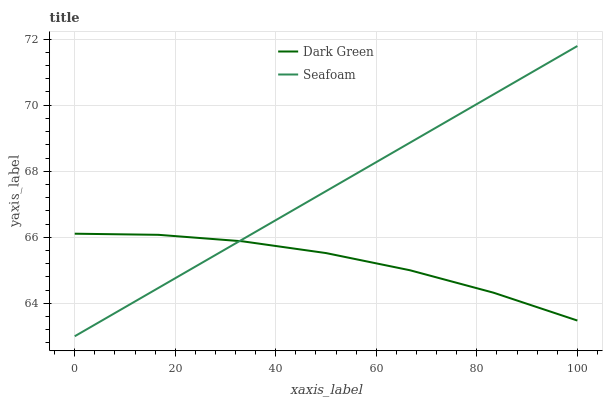Does Dark Green have the minimum area under the curve?
Answer yes or no. Yes. Does Seafoam have the maximum area under the curve?
Answer yes or no. Yes. Does Dark Green have the maximum area under the curve?
Answer yes or no. No. Is Seafoam the smoothest?
Answer yes or no. Yes. Is Dark Green the roughest?
Answer yes or no. Yes. Is Dark Green the smoothest?
Answer yes or no. No. Does Seafoam have the lowest value?
Answer yes or no. Yes. Does Dark Green have the lowest value?
Answer yes or no. No. Does Seafoam have the highest value?
Answer yes or no. Yes. Does Dark Green have the highest value?
Answer yes or no. No. Does Dark Green intersect Seafoam?
Answer yes or no. Yes. Is Dark Green less than Seafoam?
Answer yes or no. No. Is Dark Green greater than Seafoam?
Answer yes or no. No. 